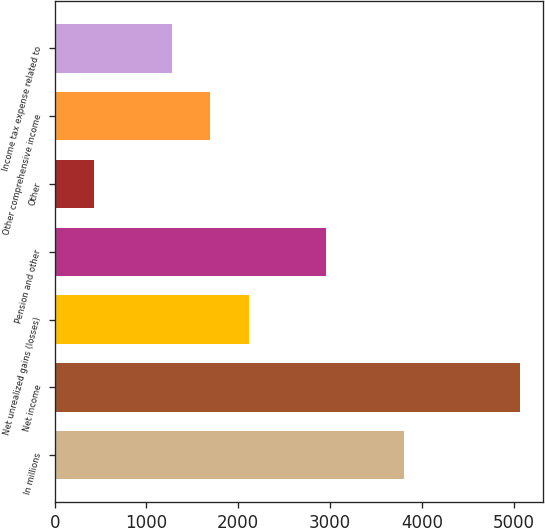Convert chart to OTSL. <chart><loc_0><loc_0><loc_500><loc_500><bar_chart><fcel>In millions<fcel>Net income<fcel>Net unrealized gains (losses)<fcel>Pension and other<fcel>Other<fcel>Other comprehensive income<fcel>Income tax expense related to<nl><fcel>3805<fcel>5071<fcel>2117<fcel>2961<fcel>429<fcel>1695<fcel>1273<nl></chart> 